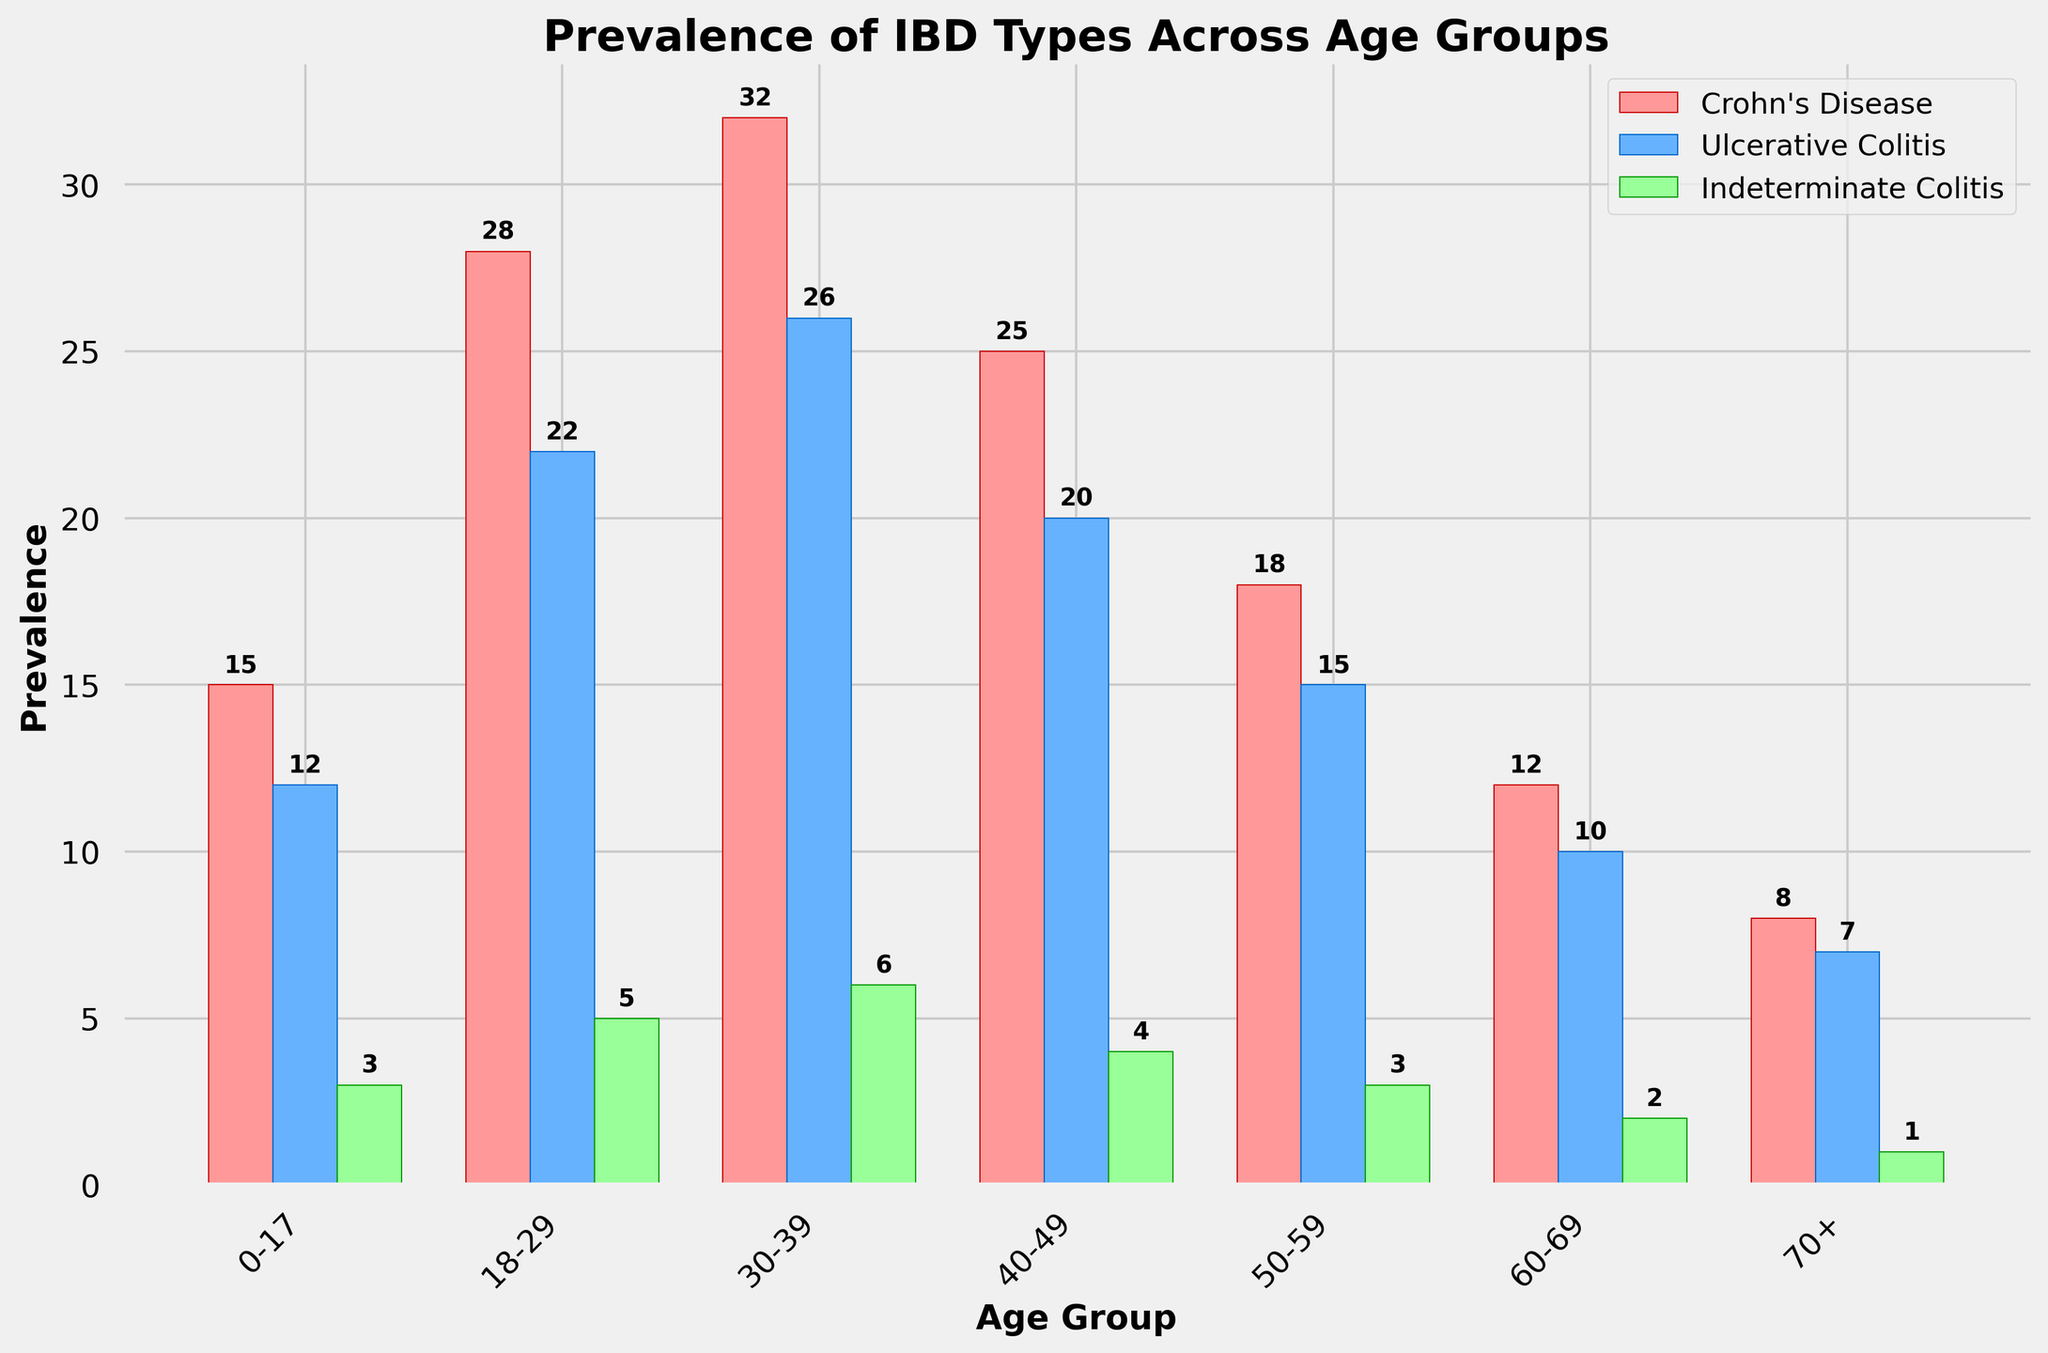Which age group has the highest prevalence of Crohn's disease? By looking at the bar heights for Crohn's disease (in red), the age group 30-39 has the highest bar.
Answer: 30-39 Which type of IBD is most common overall? By comparing the three types of bars across all age groups, Crohn's disease frequently has the highest prevalence in each age group.
Answer: Crohn's disease What is the combined prevalence of all types of IBD for the age group 0-17? We need to sum the heights of all three bars for the age group 0-17: 15 (Crohn's) + 12 (Ulcerative) + 3 (Indeterminate) = 30.
Answer: 30 In which age group is Ulcerative Colitis most prevalent? By looking at the blue bars for Ulcerative Colitis, the age group 30-39 has the highest bar.
Answer: 30-39 How does the prevalence of Crohn's disease in the 50-59 age group compare to the 18-29 age group? Crohn's disease has a prevalence of 18 in the 50-59 group and 28 in the 18-29 group, so Crohn's is less prevalent in the 50-59 age group.
Answer: Less prevalent in the 50-59 age group What is the average prevalence of Indeterminate Colitis across all age groups? To find the average, sum up the prevalence of Indeterminate Colitis across all age groups (3 + 5 + 6 + 4 + 3 + 2 + 1 = 24) and divide by the number of age groups (7). 24 / 7 ≈ 3.43.
Answer: About 3.43 Which age group has the lowest prevalence of IBD overall? By summing the bars for each age group and comparing, the age group 70+ (8 Crohn's + 7 Ulcerative + 1 Indeterminate = 16) has the lowest combined prevalence.
Answer: 70+ Is there any age group where Ulcerative Colitis is more prevalent than Crohn's disease? By comparing bar heights for Crohn's (red) and Ulcerative Colitis (blue) in each age group, there is no age group where Ulcerative Colitis is more prevalent.
Answer: No What is the total prevalence of Crohn's disease and Ulcerative Colitis for the age group 40-49? Sum the prevalence of Crohn's Disease (25) and Ulcerative Colitis (20) for the age group 40-49: 25 + 20 = 45.
Answer: 45 